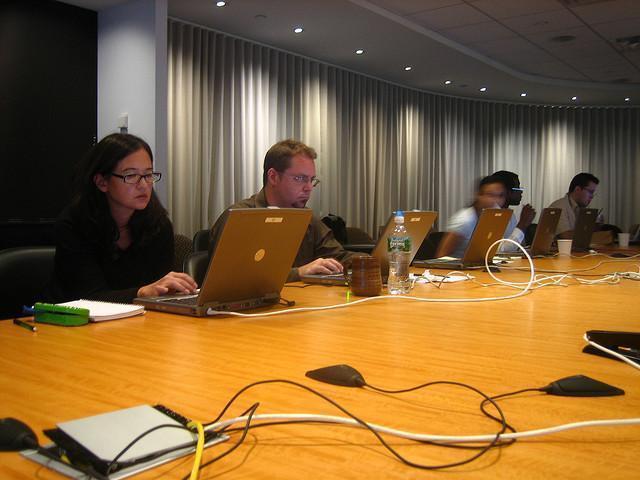What are the people doing in this venue?
Select the accurate response from the four choices given to answer the question.
Options: Studying, watching video, working, playing game. Working. 